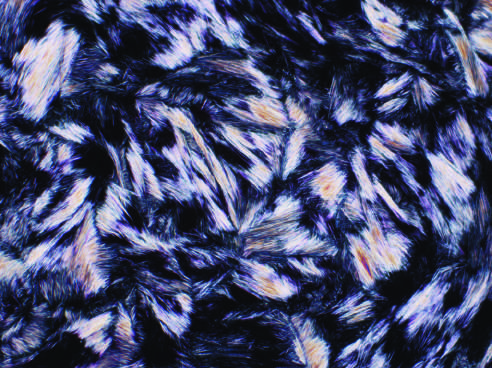what are needle shaped and negatively birefringent under polarized light?
Answer the question using a single word or phrase. Urate crystals 